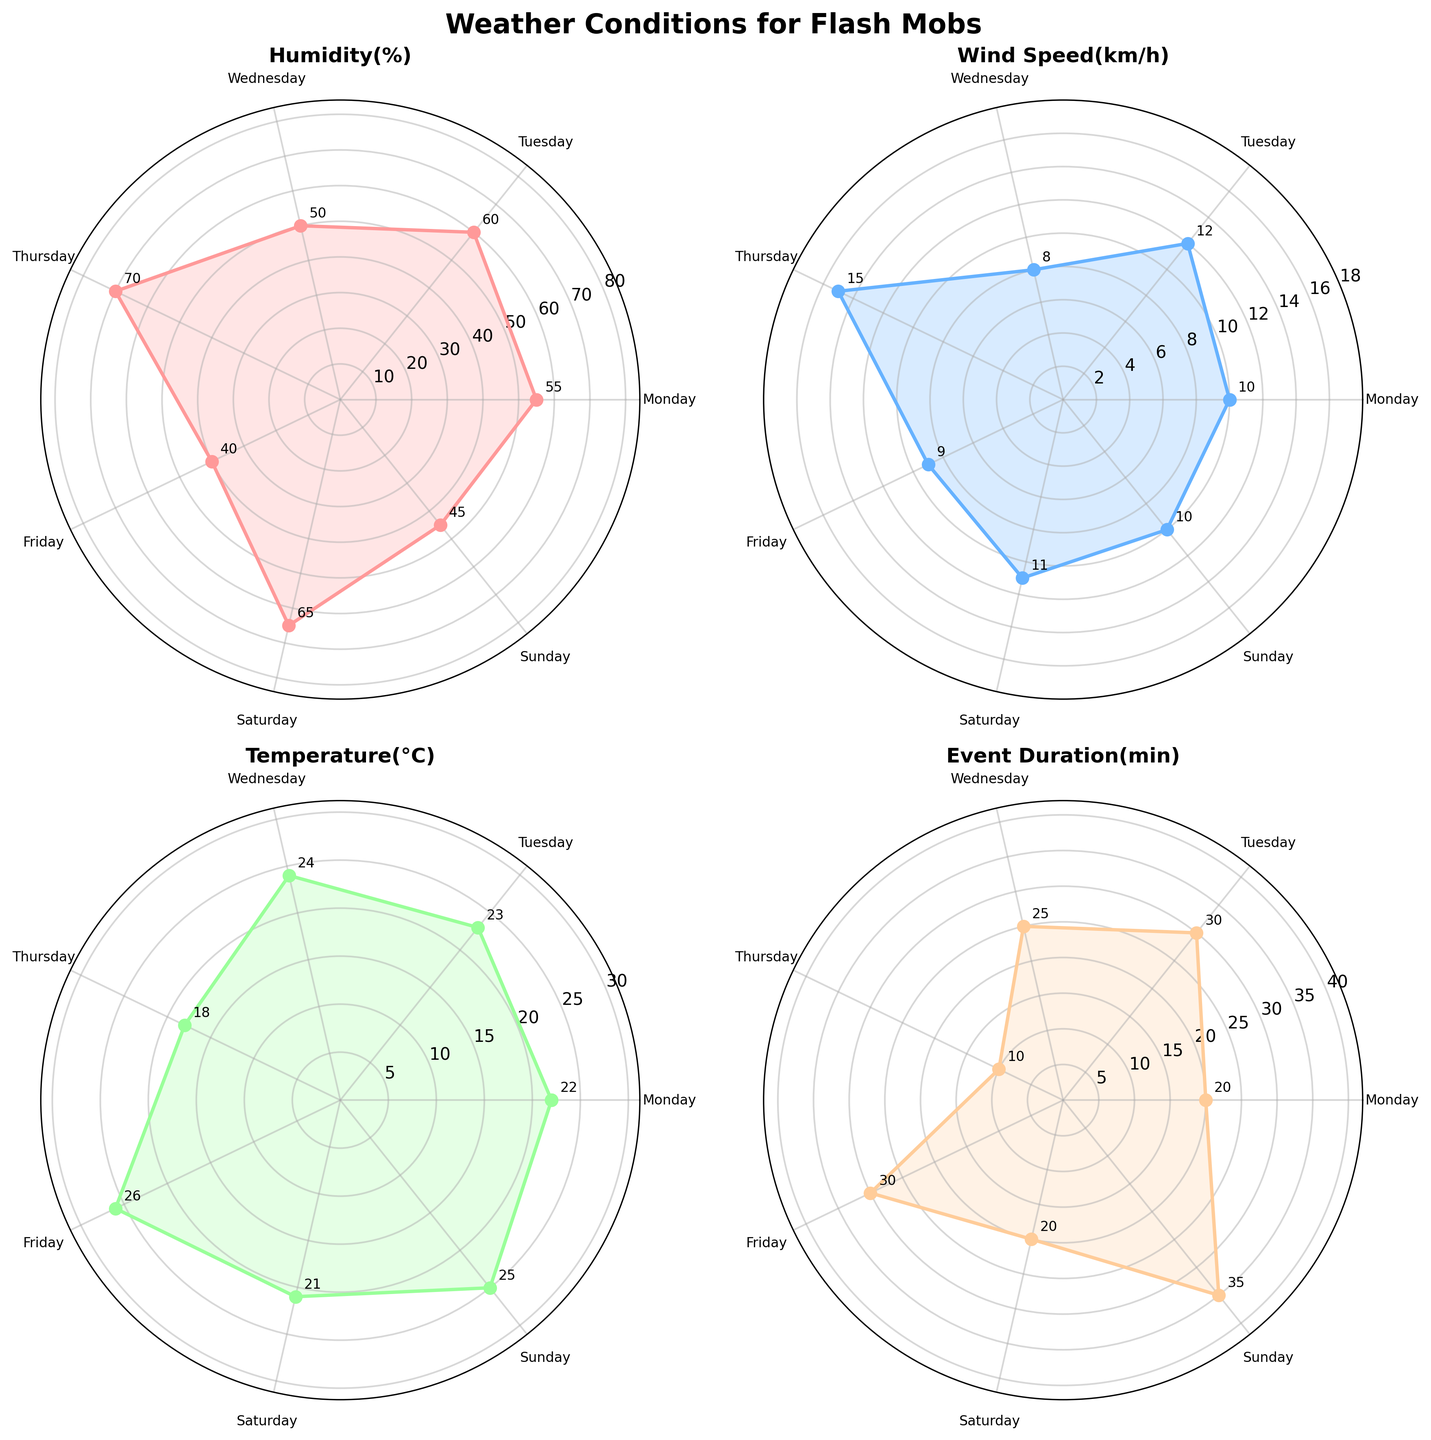What's the title of the figure? The title is located at the top center of the figure and reads "Weather Conditions for Flash Mobs"
Answer: Weather Conditions for Flash Mobs How many subplots are in the figure? The figure has a 2x2 grid of subplots, resulting in a total of four subplots
Answer: Four What weather variable has the highest value on Wednesday? By looking at the Wednesday data points across all subplots, the variable "Temperature(°C)" has the value of 24, which is the highest among all variables
Answer: Temperature(°C) Which day has the highest humidity? By checking the "Humidity(%)" subplot, the day with the highest humidity value is Thursday with 70%
Answer: Thursday What is the average wind speed from Monday to Wednesday? Adding the wind speeds from Monday (10 km/h), Tuesday (12 km/h), and Wednesday (8 km/h) and dividing by 3 gives (10 + 12 + 8) / 3 = 10 km/h
Answer: 10 km/h Which days have an event duration longer than 20 minutes? In the "Event Duration(min)" subplot, the days with values greater than 20 minutes are Tuesday (30 min), Wednesday (25 min), Friday (30 min), and Sunday (35 min)
Answer: Tuesday, Wednesday, Friday, Sunday Compare the wind speed on Thursday and Sunday. Which one is higher? In the "Wind Speed(km/h)" subplot, the wind speed on Thursday is 15 km/h whereas on Sunday it is 10 km/h, making Thursday higher
Answer: Thursday What's the range of temperature values represented in the chart? The highest temperature is on Friday (26°C) and the lowest is on Thursday (18°C), so the range is 26 - 18 = 8°C
Answer: 8°C What is the relationship between humidity and event duration on Saturday? On Saturday, the humidity is 65% and the event duration is 20 minutes. No direct correlation can be established from one data point, but Saturday's values can be noted
Answer: 65% humidity, 20 min event duration 